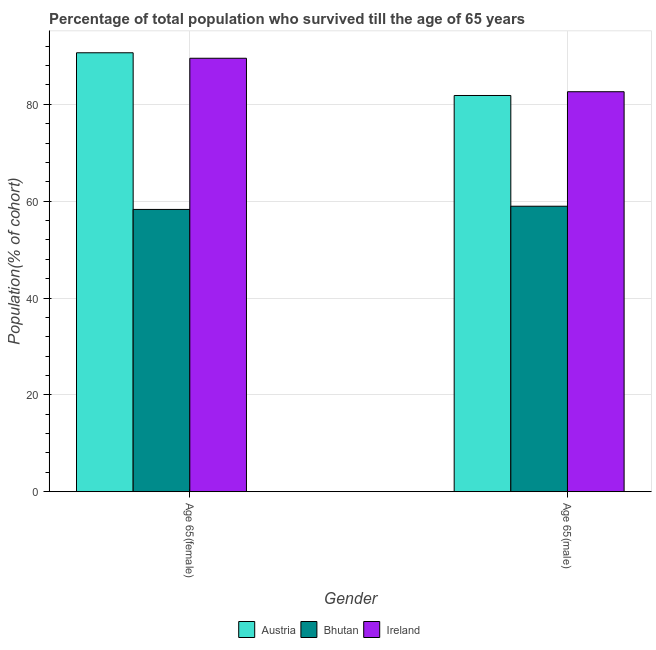How many bars are there on the 2nd tick from the left?
Keep it short and to the point. 3. What is the label of the 1st group of bars from the left?
Provide a succinct answer. Age 65(female). What is the percentage of female population who survived till age of 65 in Ireland?
Your answer should be very brief. 89.52. Across all countries, what is the maximum percentage of female population who survived till age of 65?
Ensure brevity in your answer.  90.65. Across all countries, what is the minimum percentage of female population who survived till age of 65?
Offer a terse response. 58.3. In which country was the percentage of male population who survived till age of 65 maximum?
Provide a short and direct response. Ireland. In which country was the percentage of female population who survived till age of 65 minimum?
Your answer should be compact. Bhutan. What is the total percentage of female population who survived till age of 65 in the graph?
Provide a succinct answer. 238.47. What is the difference between the percentage of male population who survived till age of 65 in Ireland and that in Austria?
Keep it short and to the point. 0.78. What is the difference between the percentage of female population who survived till age of 65 in Austria and the percentage of male population who survived till age of 65 in Bhutan?
Offer a very short reply. 31.69. What is the average percentage of female population who survived till age of 65 per country?
Offer a very short reply. 79.49. What is the difference between the percentage of female population who survived till age of 65 and percentage of male population who survived till age of 65 in Bhutan?
Provide a succinct answer. -0.66. In how many countries, is the percentage of female population who survived till age of 65 greater than 16 %?
Your answer should be very brief. 3. What is the ratio of the percentage of female population who survived till age of 65 in Austria to that in Bhutan?
Your answer should be compact. 1.55. In how many countries, is the percentage of female population who survived till age of 65 greater than the average percentage of female population who survived till age of 65 taken over all countries?
Provide a short and direct response. 2. What does the 2nd bar from the left in Age 65(male) represents?
Your answer should be very brief. Bhutan. What does the 3rd bar from the right in Age 65(male) represents?
Your answer should be compact. Austria. How many countries are there in the graph?
Make the answer very short. 3. What is the difference between two consecutive major ticks on the Y-axis?
Ensure brevity in your answer.  20. Are the values on the major ticks of Y-axis written in scientific E-notation?
Offer a very short reply. No. How many legend labels are there?
Your answer should be very brief. 3. How are the legend labels stacked?
Provide a succinct answer. Horizontal. What is the title of the graph?
Make the answer very short. Percentage of total population who survived till the age of 65 years. What is the label or title of the Y-axis?
Your response must be concise. Population(% of cohort). What is the Population(% of cohort) of Austria in Age 65(female)?
Ensure brevity in your answer.  90.65. What is the Population(% of cohort) of Bhutan in Age 65(female)?
Your answer should be compact. 58.3. What is the Population(% of cohort) of Ireland in Age 65(female)?
Keep it short and to the point. 89.52. What is the Population(% of cohort) in Austria in Age 65(male)?
Keep it short and to the point. 81.83. What is the Population(% of cohort) of Bhutan in Age 65(male)?
Provide a succinct answer. 58.96. What is the Population(% of cohort) in Ireland in Age 65(male)?
Give a very brief answer. 82.61. Across all Gender, what is the maximum Population(% of cohort) in Austria?
Keep it short and to the point. 90.65. Across all Gender, what is the maximum Population(% of cohort) in Bhutan?
Make the answer very short. 58.96. Across all Gender, what is the maximum Population(% of cohort) in Ireland?
Offer a very short reply. 89.52. Across all Gender, what is the minimum Population(% of cohort) of Austria?
Provide a short and direct response. 81.83. Across all Gender, what is the minimum Population(% of cohort) in Bhutan?
Your answer should be very brief. 58.3. Across all Gender, what is the minimum Population(% of cohort) of Ireland?
Your response must be concise. 82.61. What is the total Population(% of cohort) of Austria in the graph?
Offer a terse response. 172.48. What is the total Population(% of cohort) in Bhutan in the graph?
Your answer should be compact. 117.26. What is the total Population(% of cohort) in Ireland in the graph?
Give a very brief answer. 172.13. What is the difference between the Population(% of cohort) of Austria in Age 65(female) and that in Age 65(male)?
Your response must be concise. 8.82. What is the difference between the Population(% of cohort) of Bhutan in Age 65(female) and that in Age 65(male)?
Offer a terse response. -0.66. What is the difference between the Population(% of cohort) of Ireland in Age 65(female) and that in Age 65(male)?
Ensure brevity in your answer.  6.91. What is the difference between the Population(% of cohort) in Austria in Age 65(female) and the Population(% of cohort) in Bhutan in Age 65(male)?
Make the answer very short. 31.69. What is the difference between the Population(% of cohort) in Austria in Age 65(female) and the Population(% of cohort) in Ireland in Age 65(male)?
Provide a succinct answer. 8.04. What is the difference between the Population(% of cohort) of Bhutan in Age 65(female) and the Population(% of cohort) of Ireland in Age 65(male)?
Provide a short and direct response. -24.31. What is the average Population(% of cohort) in Austria per Gender?
Provide a succinct answer. 86.24. What is the average Population(% of cohort) in Bhutan per Gender?
Provide a short and direct response. 58.63. What is the average Population(% of cohort) in Ireland per Gender?
Offer a very short reply. 86.06. What is the difference between the Population(% of cohort) of Austria and Population(% of cohort) of Bhutan in Age 65(female)?
Provide a short and direct response. 32.35. What is the difference between the Population(% of cohort) in Austria and Population(% of cohort) in Ireland in Age 65(female)?
Make the answer very short. 1.13. What is the difference between the Population(% of cohort) in Bhutan and Population(% of cohort) in Ireland in Age 65(female)?
Give a very brief answer. -31.22. What is the difference between the Population(% of cohort) in Austria and Population(% of cohort) in Bhutan in Age 65(male)?
Your response must be concise. 22.87. What is the difference between the Population(% of cohort) in Austria and Population(% of cohort) in Ireland in Age 65(male)?
Your response must be concise. -0.78. What is the difference between the Population(% of cohort) of Bhutan and Population(% of cohort) of Ireland in Age 65(male)?
Offer a terse response. -23.65. What is the ratio of the Population(% of cohort) in Austria in Age 65(female) to that in Age 65(male)?
Offer a very short reply. 1.11. What is the ratio of the Population(% of cohort) of Bhutan in Age 65(female) to that in Age 65(male)?
Keep it short and to the point. 0.99. What is the ratio of the Population(% of cohort) in Ireland in Age 65(female) to that in Age 65(male)?
Offer a terse response. 1.08. What is the difference between the highest and the second highest Population(% of cohort) of Austria?
Keep it short and to the point. 8.82. What is the difference between the highest and the second highest Population(% of cohort) of Bhutan?
Provide a succinct answer. 0.66. What is the difference between the highest and the second highest Population(% of cohort) in Ireland?
Ensure brevity in your answer.  6.91. What is the difference between the highest and the lowest Population(% of cohort) of Austria?
Provide a succinct answer. 8.82. What is the difference between the highest and the lowest Population(% of cohort) in Bhutan?
Give a very brief answer. 0.66. What is the difference between the highest and the lowest Population(% of cohort) in Ireland?
Offer a very short reply. 6.91. 